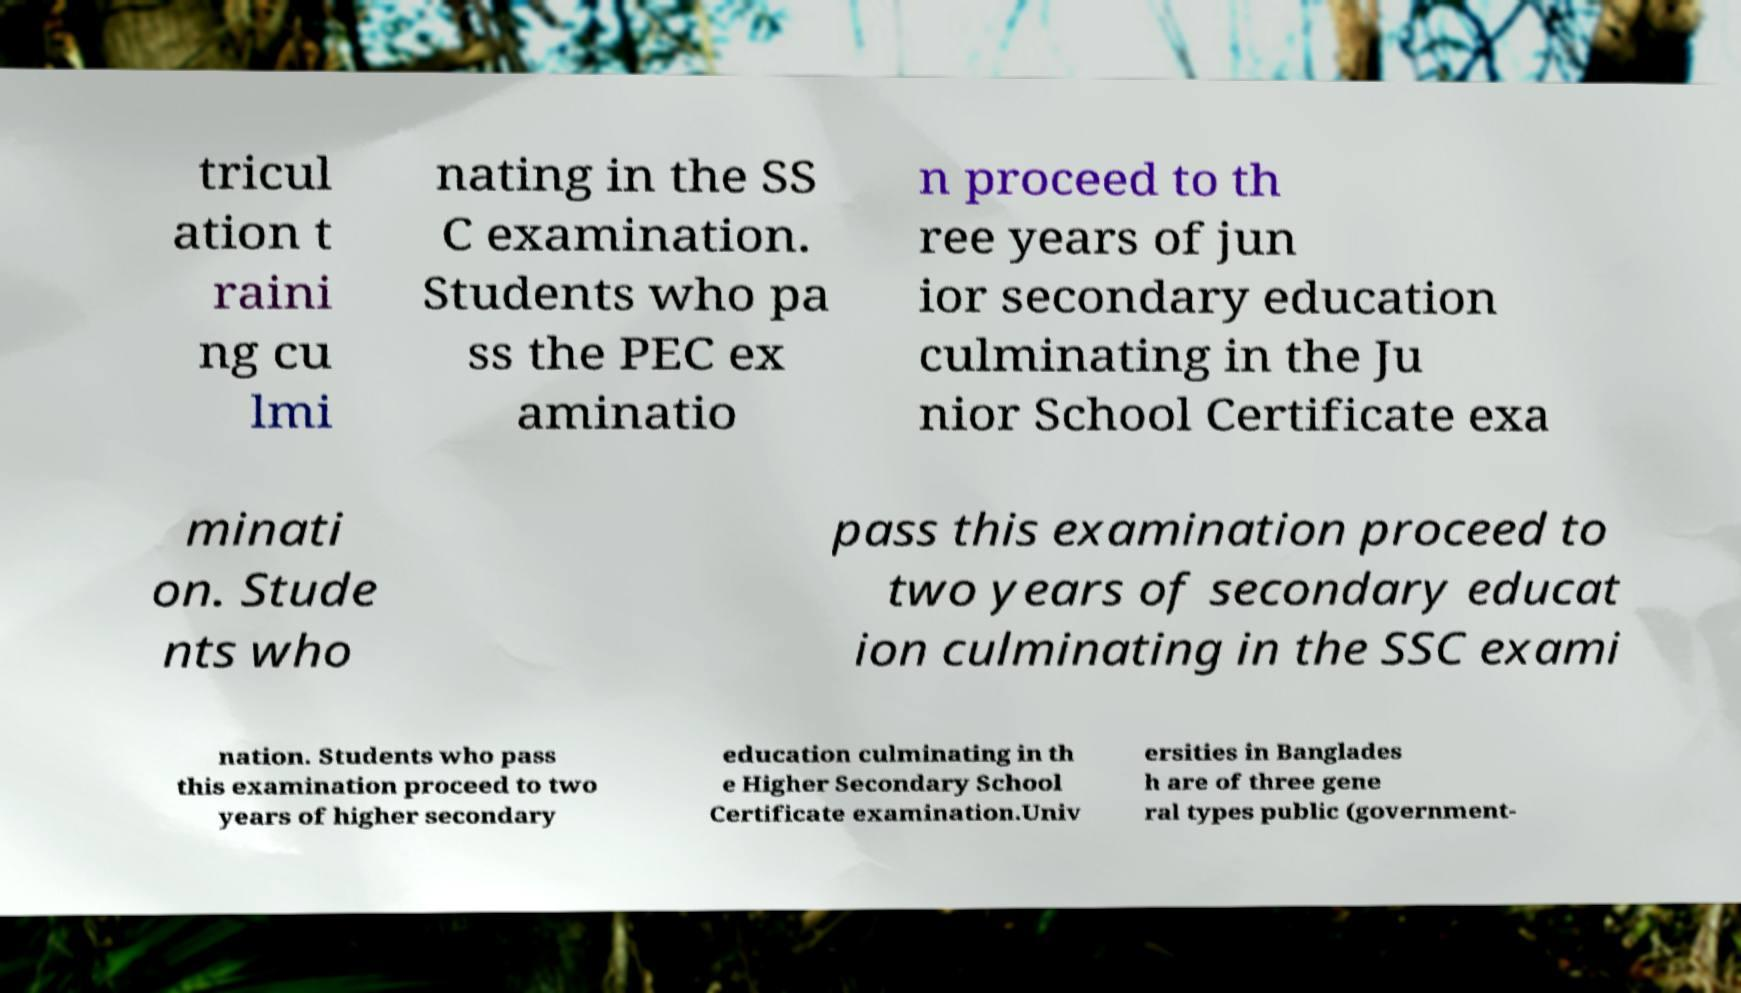What messages or text are displayed in this image? I need them in a readable, typed format. tricul ation t raini ng cu lmi nating in the SS C examination. Students who pa ss the PEC ex aminatio n proceed to th ree years of jun ior secondary education culminating in the Ju nior School Certificate exa minati on. Stude nts who pass this examination proceed to two years of secondary educat ion culminating in the SSC exami nation. Students who pass this examination proceed to two years of higher secondary education culminating in th e Higher Secondary School Certificate examination.Univ ersities in Banglades h are of three gene ral types public (government- 